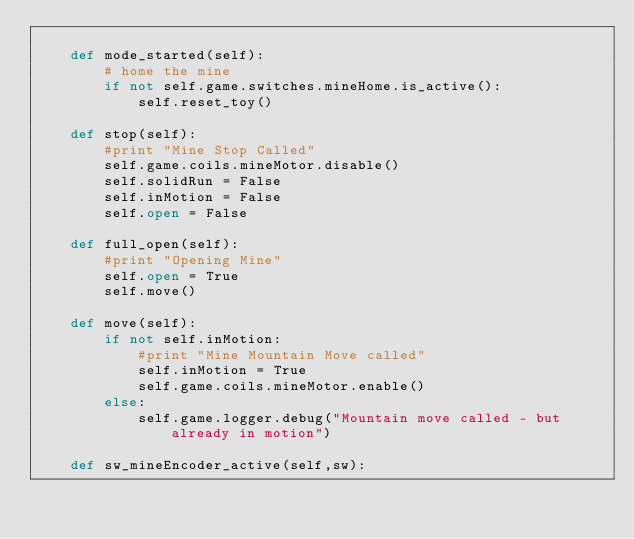Convert code to text. <code><loc_0><loc_0><loc_500><loc_500><_Python_>
    def mode_started(self):
        # home the mine
        if not self.game.switches.mineHome.is_active():
            self.reset_toy()

    def stop(self):
        #print "Mine Stop Called"
        self.game.coils.mineMotor.disable()
        self.solidRun = False
        self.inMotion = False
        self.open = False

    def full_open(self):
        #print "Opening Mine"
        self.open = True
        self.move()

    def move(self):
        if not self.inMotion:
            #print "Mine Mountain Move called"
            self.inMotion = True
            self.game.coils.mineMotor.enable()
        else:
            self.game.logger.debug("Mountain move called - but already in motion")

    def sw_mineEncoder_active(self,sw):</code> 